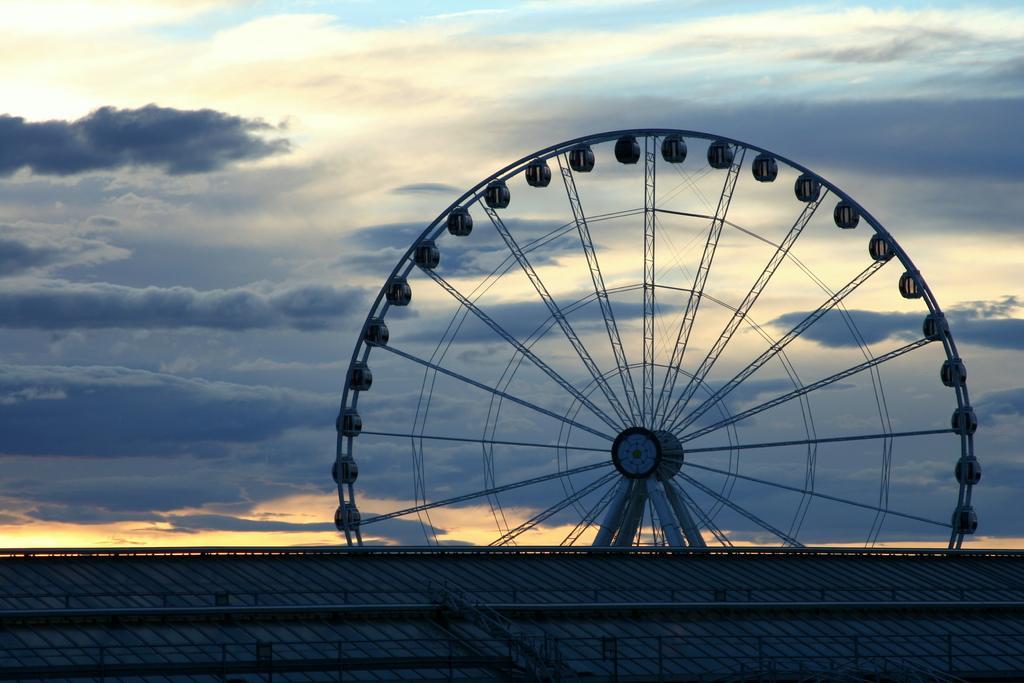Describe this image in one or two sentences. In the center of the image we can see a giant wheel. At the bottom there is a fence. In the background there is sky. 